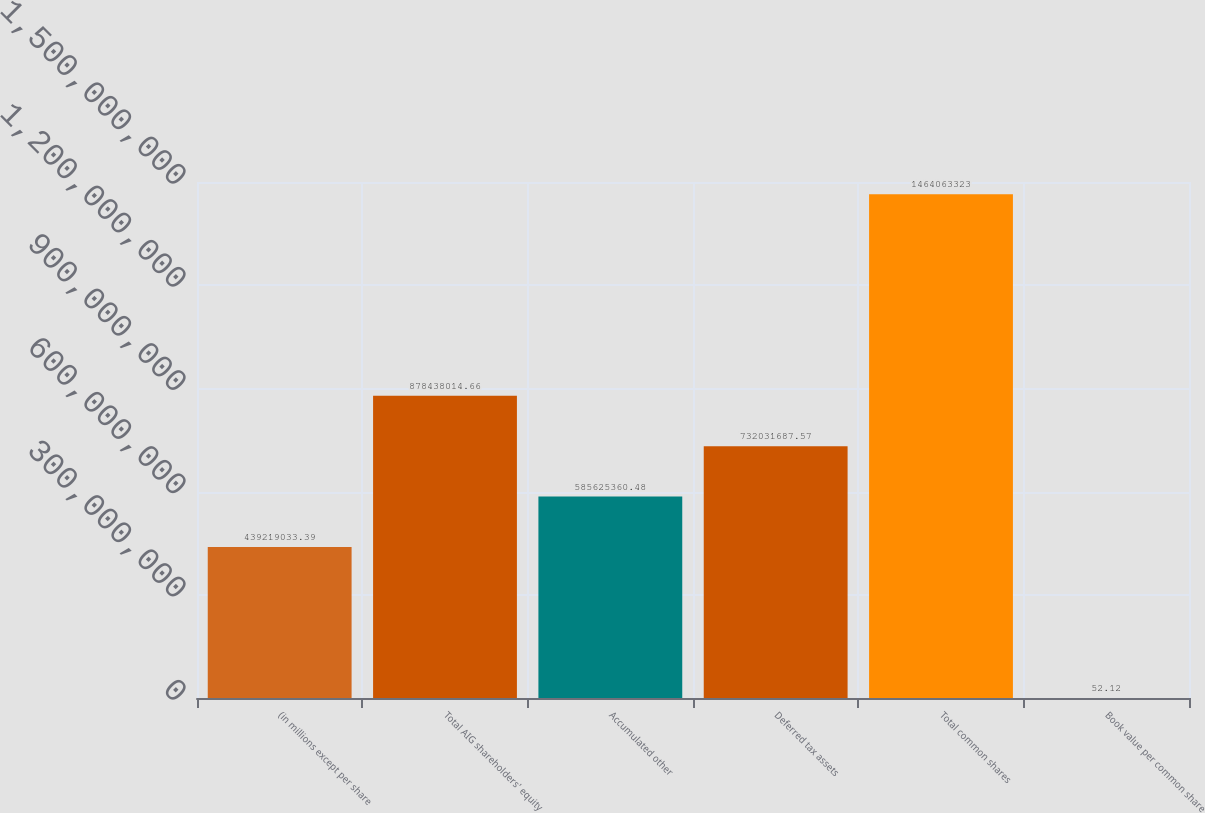<chart> <loc_0><loc_0><loc_500><loc_500><bar_chart><fcel>(in millions except per share<fcel>Total AIG shareholders' equity<fcel>Accumulated other<fcel>Deferred tax assets<fcel>Total common shares<fcel>Book value per common share<nl><fcel>4.39219e+08<fcel>8.78438e+08<fcel>5.85625e+08<fcel>7.32032e+08<fcel>1.46406e+09<fcel>52.12<nl></chart> 